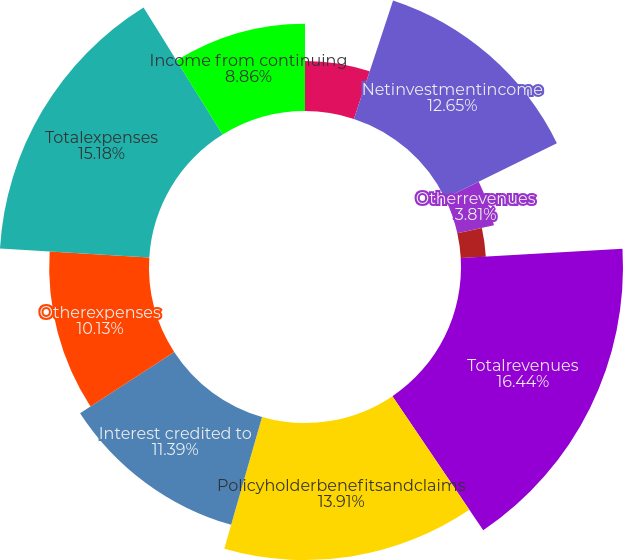Convert chart to OTSL. <chart><loc_0><loc_0><loc_500><loc_500><pie_chart><ecel><fcel>Netinvestmentincome<fcel>Otherrevenues<fcel>Netinvestmentgains(losses)<fcel>Totalrevenues<fcel>Policyholderbenefitsandclaims<fcel>Interest credited to<fcel>Otherexpenses<fcel>Totalexpenses<fcel>Income from continuing<nl><fcel>5.08%<fcel>12.65%<fcel>3.81%<fcel>2.55%<fcel>16.44%<fcel>13.91%<fcel>11.39%<fcel>10.13%<fcel>15.18%<fcel>8.86%<nl></chart> 